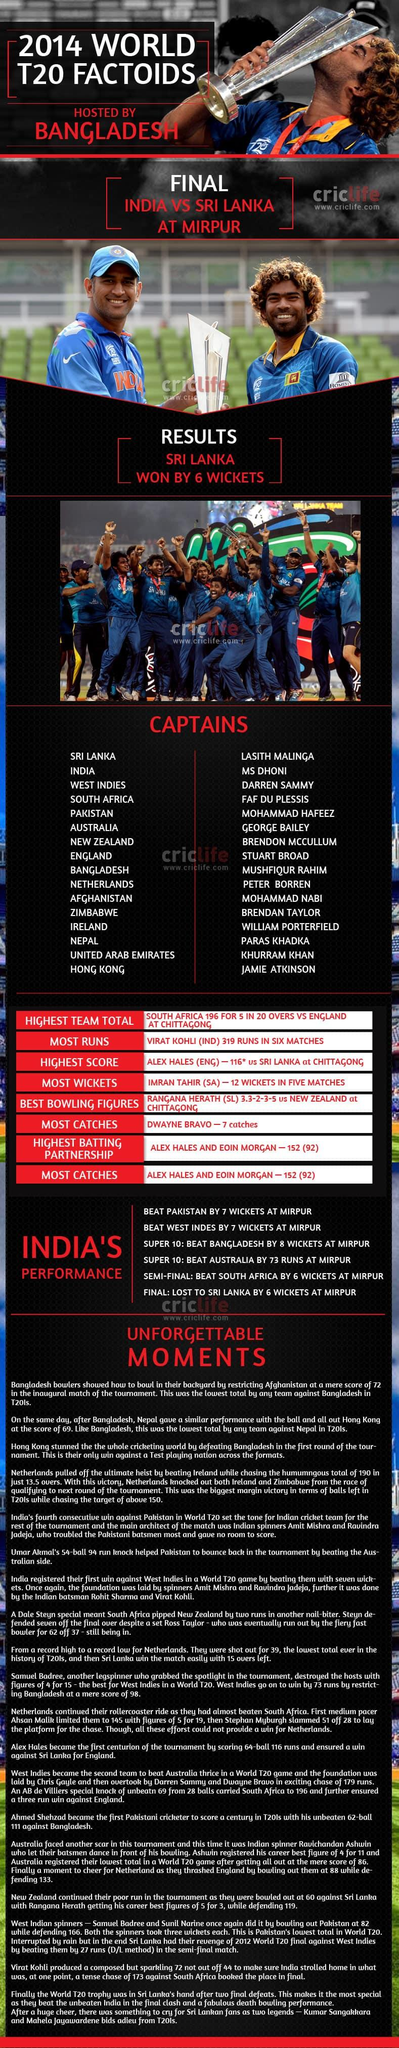Specify some key components in this picture. In India's performance highlights, all matches were held in Mirpur. The captains Lasith Malinga and MS Dhoni are currently holding the cup. Alex Hales and Eoin Morgan were presented with awards for the highest batting partnership and most catches, respectively, during the match. I, Lasith Malinga, am the captain who is currently kissing the cup. Sri Lanka defeated India, whom. 